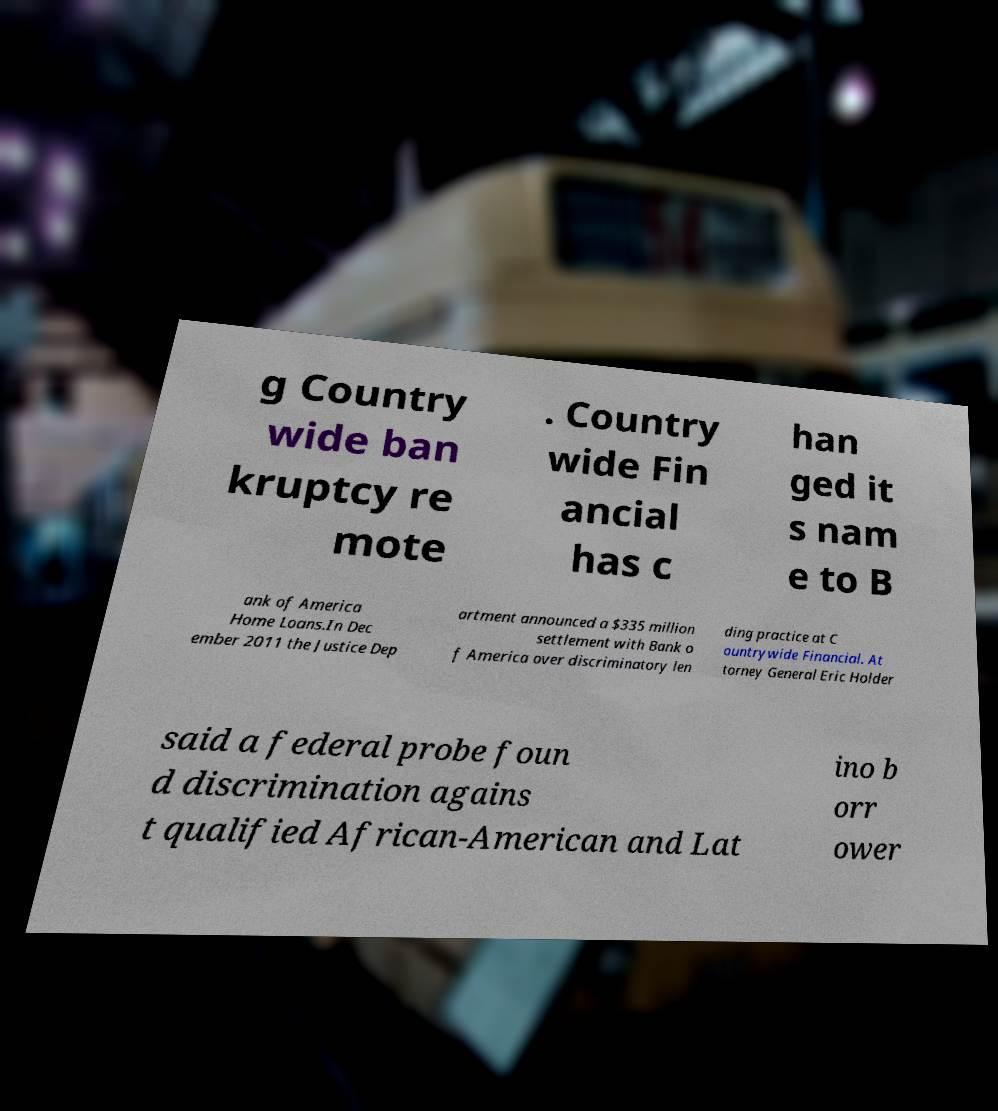Please read and relay the text visible in this image. What does it say? g Country wide ban kruptcy re mote . Country wide Fin ancial has c han ged it s nam e to B ank of America Home Loans.In Dec ember 2011 the Justice Dep artment announced a $335 million settlement with Bank o f America over discriminatory len ding practice at C ountrywide Financial. At torney General Eric Holder said a federal probe foun d discrimination agains t qualified African-American and Lat ino b orr ower 